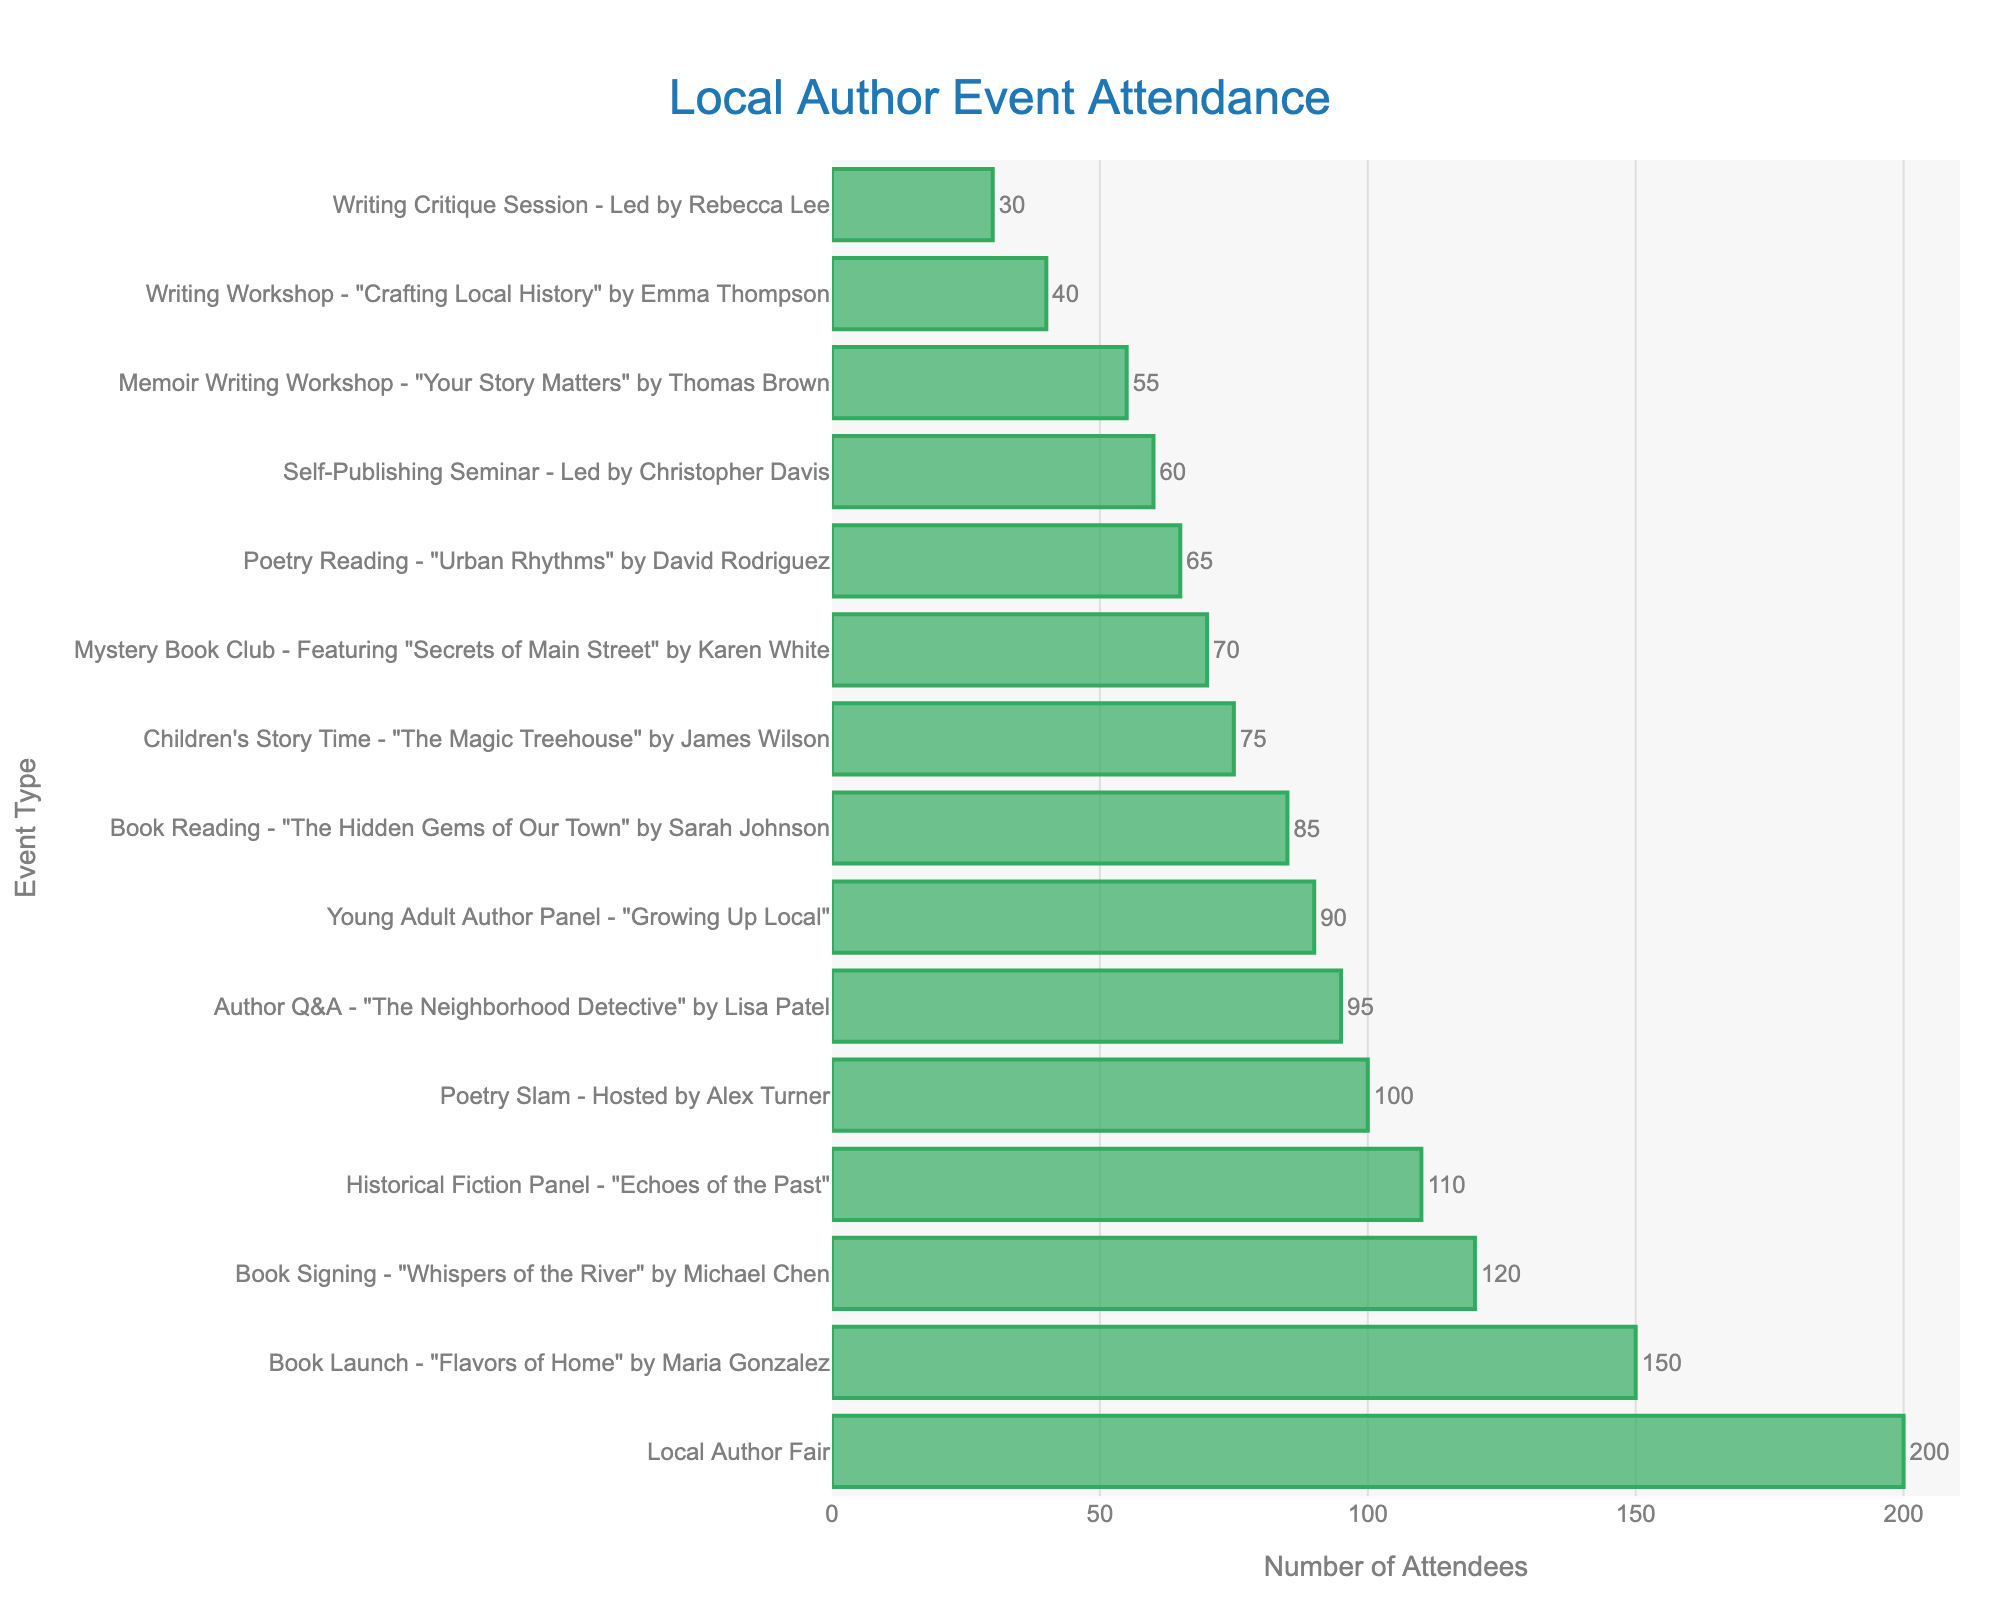Which event had the highest attendance? To determine which event had the highest attendance, look for the longest bar on the bar chart. This bar represents the Book Launch - "Flavors of Home" by Maria Gonzalez with 150 attendees.
Answer: Book Launch - "Flavors of Home" What was the total attendance for all book reading and poetry events combined? First, identify all events that fall under the categories of book readings and poetry: "The Hidden Gems of Our Town" (85), "Urban Rhythms" (65), and Poetry Slam (100). Then, add these figures: 85 + 65 + 100 = 250.
Answer: 250 How many more attendees attended the Local Author Fair compared to the Author Q&A? Identify the attendance for Local Author Fair (200) and Author Q&A (95). Calculate the difference: 200 - 95 = 105.
Answer: 105 Which event had the lowest attendance? To find the event with the lowest attendance, look for the shortest bar on the bar chart. This bar represents the Writing Critique Session led by Rebecca Lee with 30 attendees.
Answer: Writing Critique Session How does the attendance of the Historical Fiction Panel compare to the Young Adult Author Panel? Find the attendance figures for both events: Historical Fiction Panel (110) and Young Adult Author Panel (90). Compare these figures to determine that the Historical Fiction Panel had a higher attendance.
Answer: Historical Fiction Panel had more attendees What is the average attendance of the event types listed? Sum all the attendance figures and divide by the number of events. Total attendance is 85 + 120 + 40 + 65 + 95 + 150 + 75 + 110 + 200 + 30 + 55 + 70 + 100 + 90 + 60 = 1345. There are 15 events, so average attendance is 1345 / 15 ≈ 89.7.
Answer: 89.7 Which event had more attendees: the Self-Publishing Seminar or the Memoir Writing Workshop? Compare the attendance figures of the Self-Publishing Seminar (60) and the Memoir Writing Workshop (55). The Self-Publishing Seminar had more attendees.
Answer: Self-Publishing Seminar What is the median attendance of the events? List the attendance figures in ascending order: 30, 40, 55, 60, 65, 70, 75, 85, 90, 95, 100, 110, 120, 150, 200. The median is the middle number in this ordered list, which is 85.
Answer: 85 